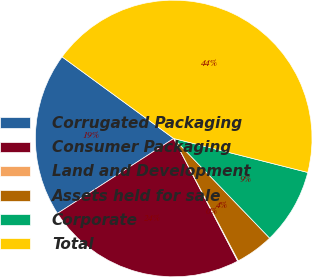Convert chart to OTSL. <chart><loc_0><loc_0><loc_500><loc_500><pie_chart><fcel>Corrugated Packaging<fcel>Consumer Packaging<fcel>Land and Development<fcel>Assets held for sale<fcel>Corporate<fcel>Total<nl><fcel>19.16%<fcel>23.54%<fcel>0.08%<fcel>4.47%<fcel>8.85%<fcel>43.9%<nl></chart> 